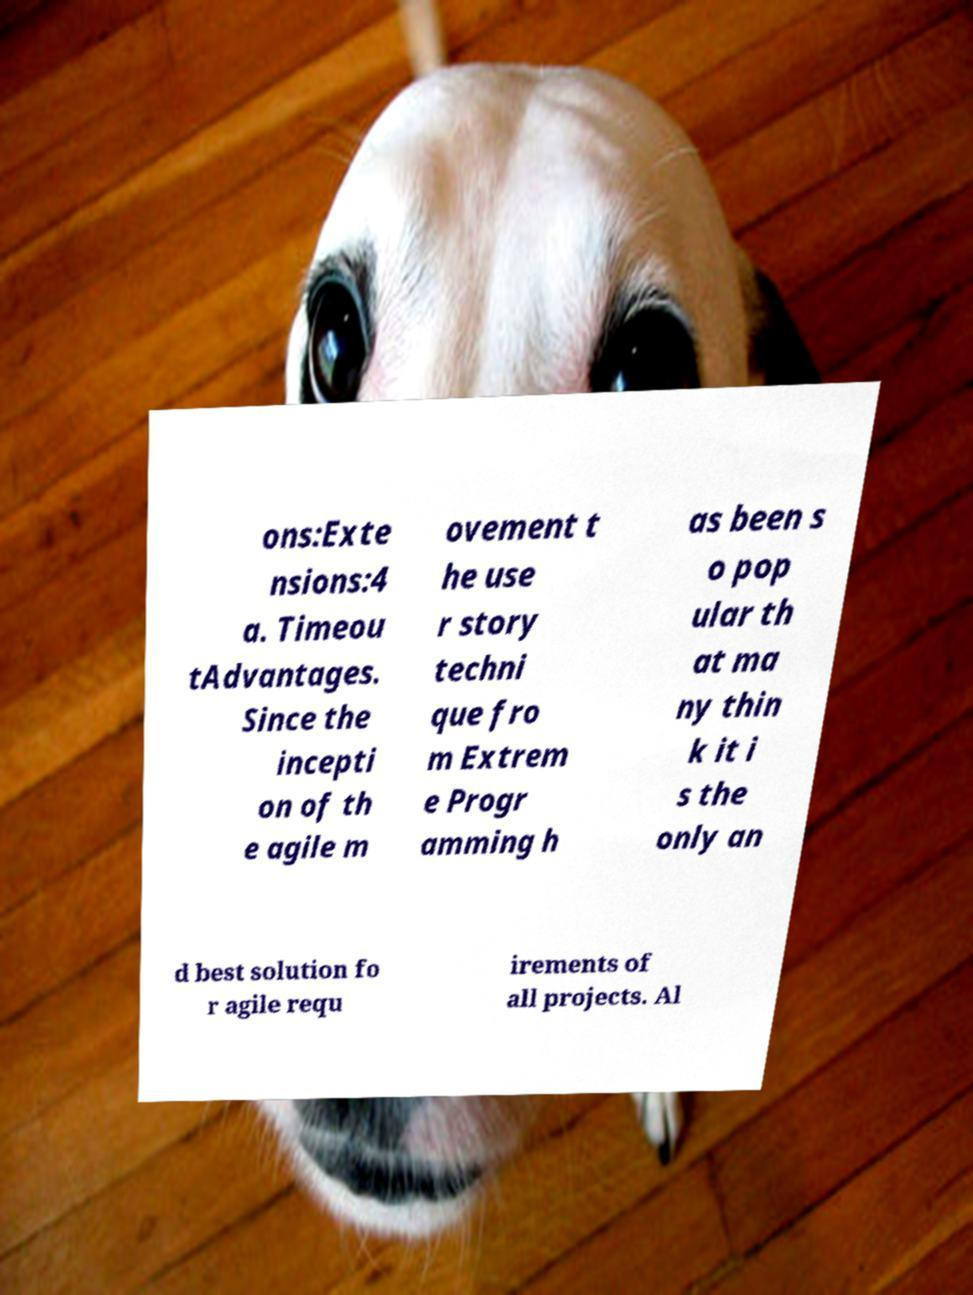Can you accurately transcribe the text from the provided image for me? ons:Exte nsions:4 a. Timeou tAdvantages. Since the incepti on of th e agile m ovement t he use r story techni que fro m Extrem e Progr amming h as been s o pop ular th at ma ny thin k it i s the only an d best solution fo r agile requ irements of all projects. Al 